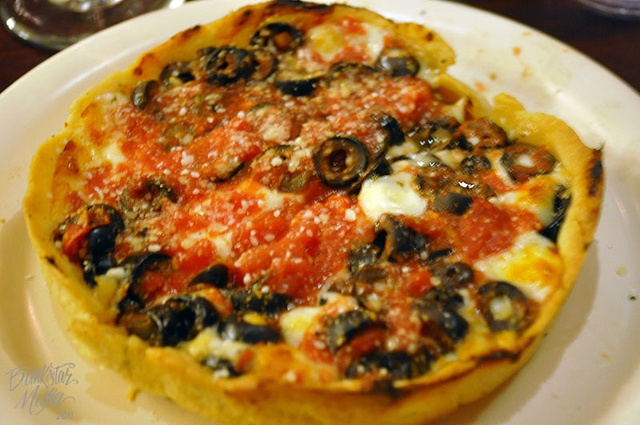Describe the objects in this image and their specific colors. I can see pizza in black, red, orange, and maroon tones and cup in white, black, olive, maroon, and gray tones in this image. 